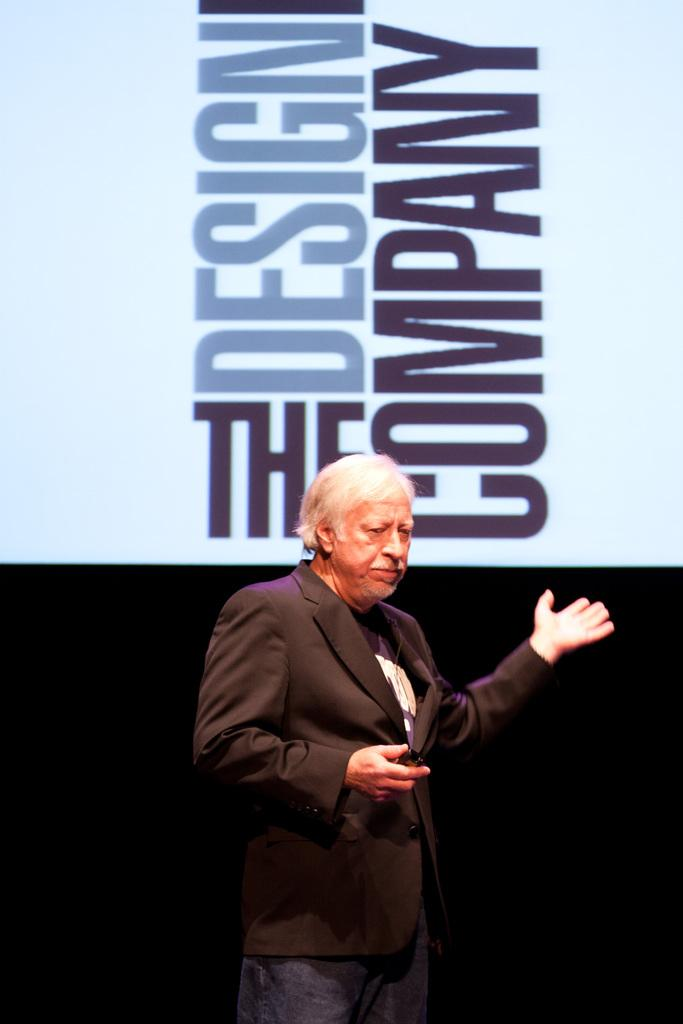<image>
Present a compact description of the photo's key features. A man stands in front of large text that reads "The Design Company". 